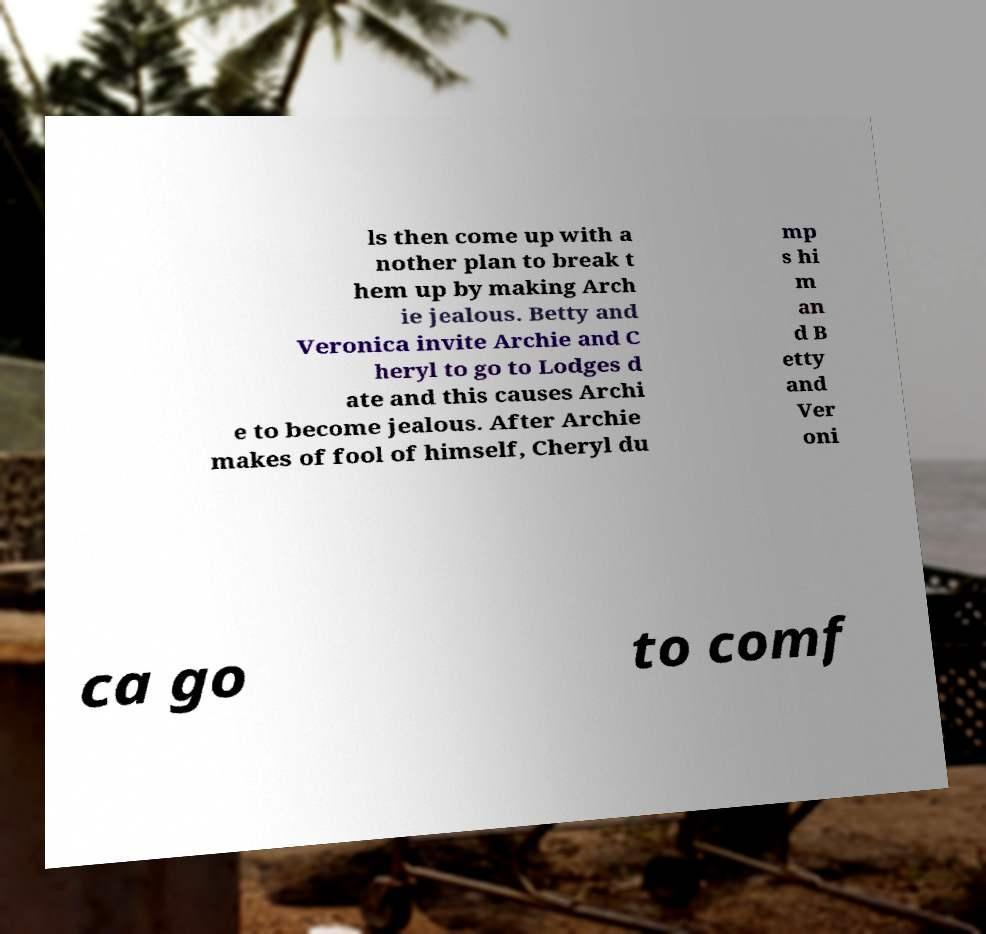I need the written content from this picture converted into text. Can you do that? ls then come up with a nother plan to break t hem up by making Arch ie jealous. Betty and Veronica invite Archie and C heryl to go to Lodges d ate and this causes Archi e to become jealous. After Archie makes of fool of himself, Cheryl du mp s hi m an d B etty and Ver oni ca go to comf 